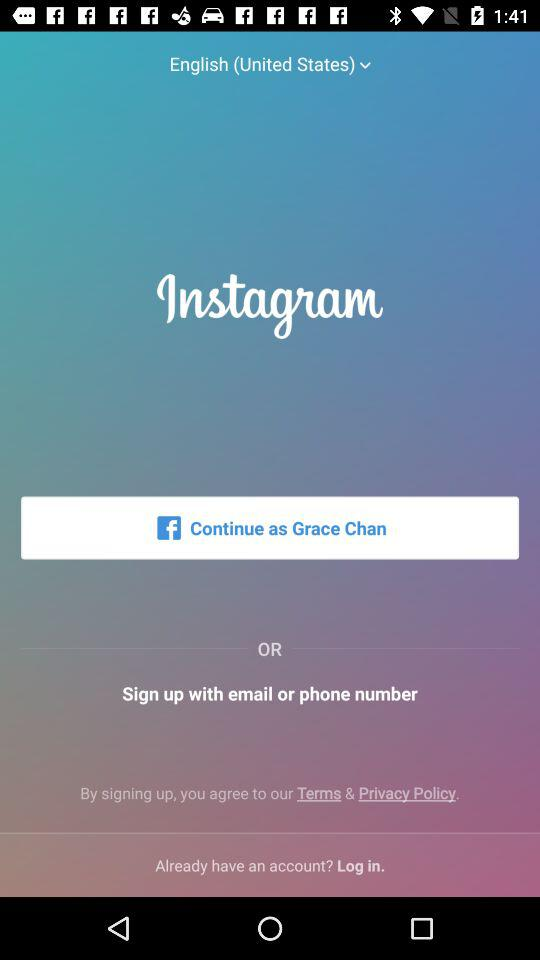What is the user name? The user name is Grace Chan. 